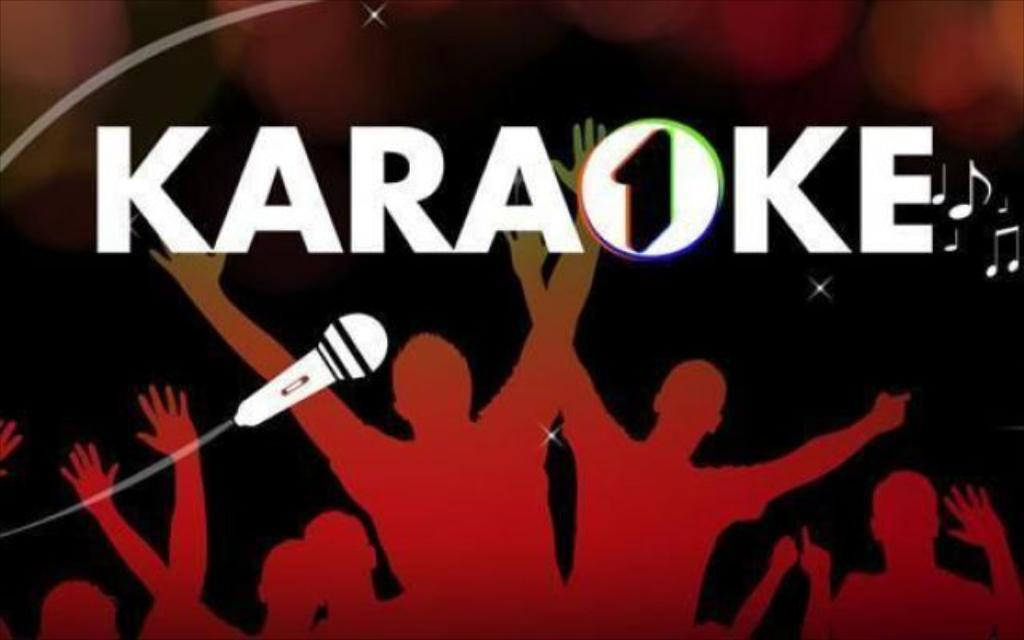<image>
Render a clear and concise summary of the photo. Sign that has people and a microphone with the word Karaoke on top. 